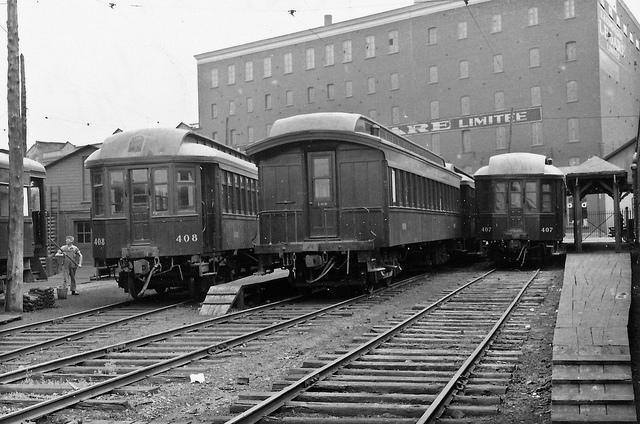How many buildings are in the background?
Give a very brief answer. 1. How many trains are on the track?
Give a very brief answer. 3. How many trains are there?
Give a very brief answer. 3. How many trains can be seen?
Give a very brief answer. 4. 